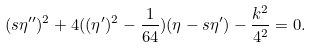Convert formula to latex. <formula><loc_0><loc_0><loc_500><loc_500>( s \eta ^ { \prime \prime } ) ^ { 2 } + 4 ( ( \eta ^ { \prime } ) ^ { 2 } - \frac { 1 } { 6 4 } ) ( \eta - s \eta ^ { \prime } ) - \frac { k ^ { 2 } } { 4 ^ { 2 } } = 0 .</formula> 